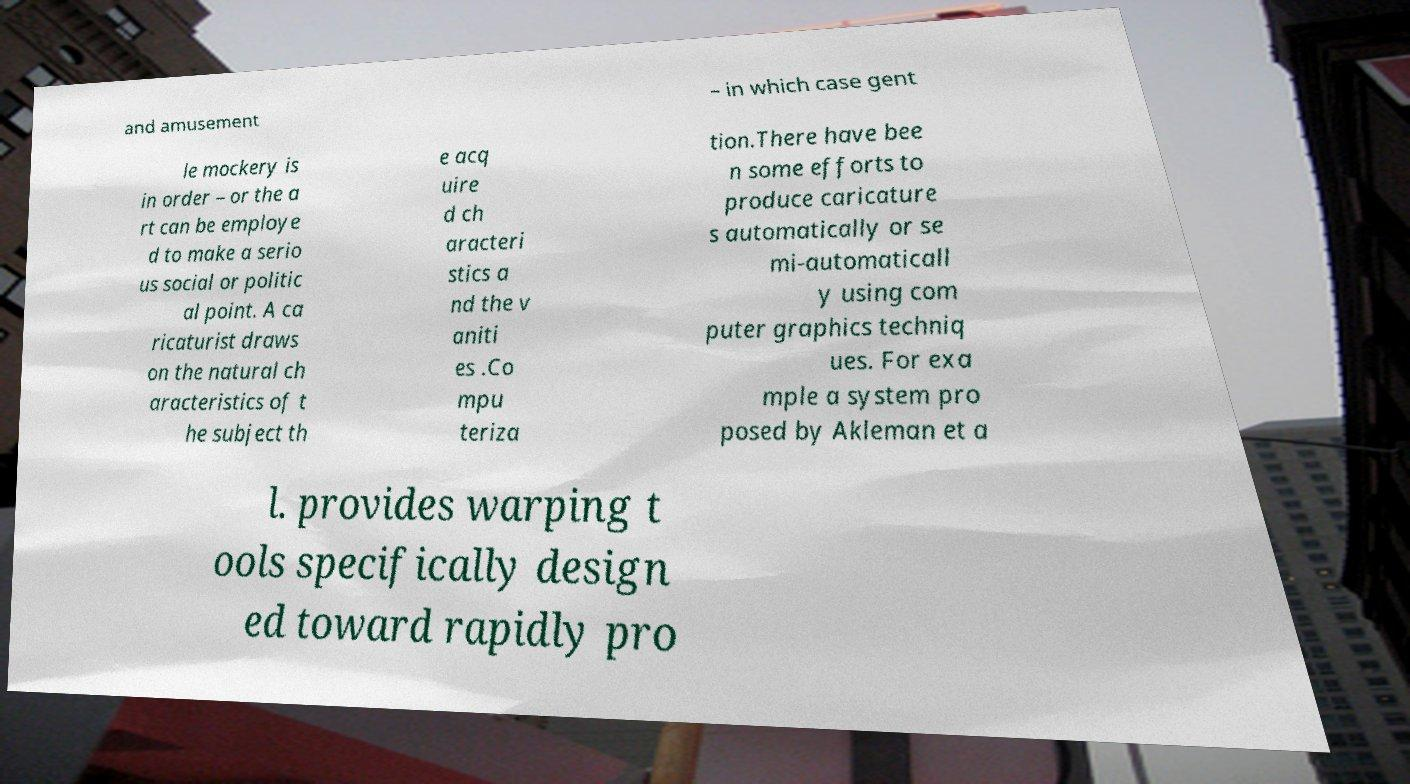I need the written content from this picture converted into text. Can you do that? and amusement – in which case gent le mockery is in order – or the a rt can be employe d to make a serio us social or politic al point. A ca ricaturist draws on the natural ch aracteristics of t he subject th e acq uire d ch aracteri stics a nd the v aniti es .Co mpu teriza tion.There have bee n some efforts to produce caricature s automatically or se mi-automaticall y using com puter graphics techniq ues. For exa mple a system pro posed by Akleman et a l. provides warping t ools specifically design ed toward rapidly pro 